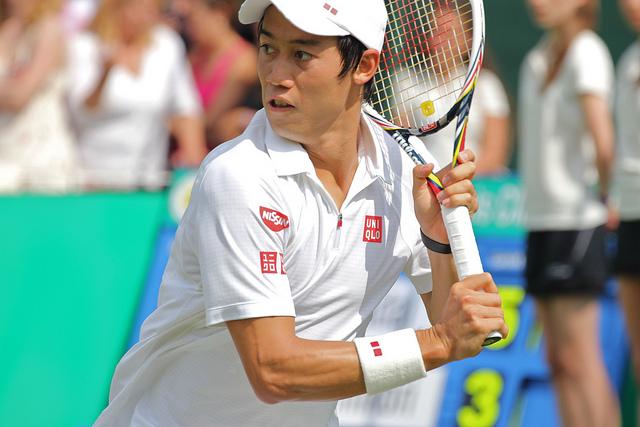What color is the man's shirt?
Give a very brief answer. White. What is the person holding in his hands?
Short answer required. Tennis racquet. What sport is the man playing?
Be succinct. Tennis. Is it waiting to hit the ball?
Keep it brief. Yes. 